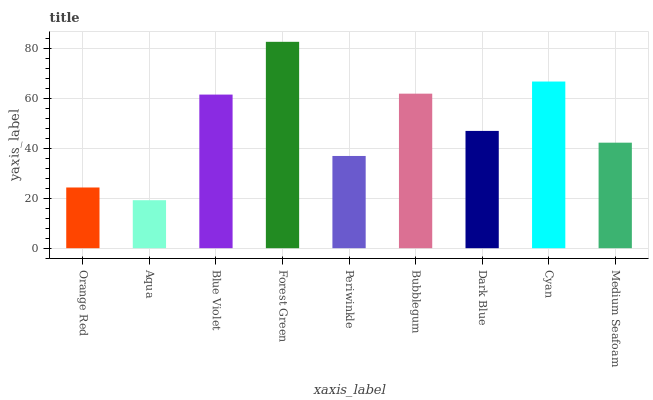Is Aqua the minimum?
Answer yes or no. Yes. Is Forest Green the maximum?
Answer yes or no. Yes. Is Blue Violet the minimum?
Answer yes or no. No. Is Blue Violet the maximum?
Answer yes or no. No. Is Blue Violet greater than Aqua?
Answer yes or no. Yes. Is Aqua less than Blue Violet?
Answer yes or no. Yes. Is Aqua greater than Blue Violet?
Answer yes or no. No. Is Blue Violet less than Aqua?
Answer yes or no. No. Is Dark Blue the high median?
Answer yes or no. Yes. Is Dark Blue the low median?
Answer yes or no. Yes. Is Periwinkle the high median?
Answer yes or no. No. Is Blue Violet the low median?
Answer yes or no. No. 